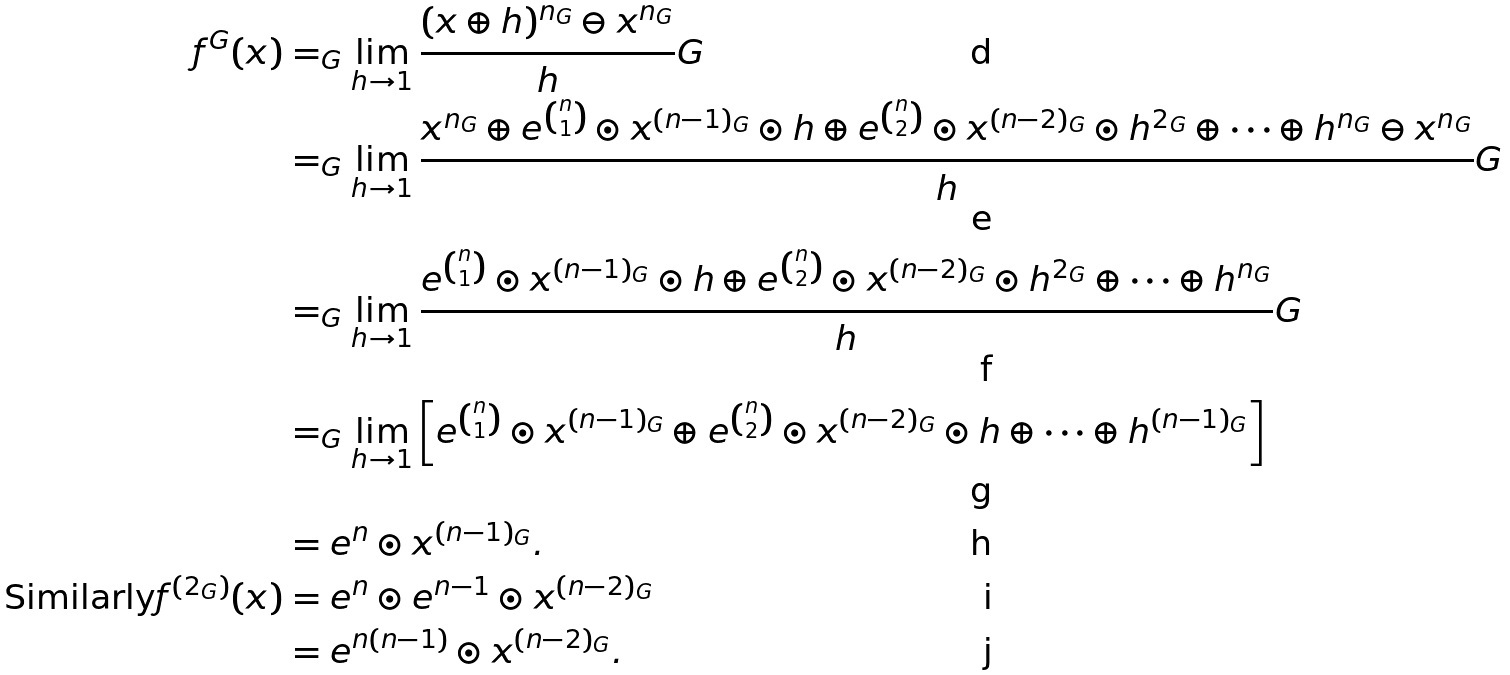Convert formula to latex. <formula><loc_0><loc_0><loc_500><loc_500>f ^ { G } ( x ) & = _ { G } \lim _ { h \rightarrow 1 } \frac { ( x \oplus h ) ^ { n _ { G } } \ominus x ^ { n _ { G } } } { h } G \\ & = _ { G } \lim _ { h \rightarrow 1 } \frac { x ^ { n _ { G } } \oplus e ^ { \binom { n } { 1 } } \odot x ^ { ( n - 1 ) _ { G } } \odot h \oplus e ^ { \binom { n } { 2 } } \odot x ^ { ( n - 2 ) _ { G } } \odot h ^ { 2 _ { G } } \oplus \cdots \oplus h ^ { n _ { G } } \ominus x ^ { n _ { G } } } { h } G \\ & = _ { G } \lim _ { h \rightarrow 1 } \frac { e ^ { \binom { n } { 1 } } \odot x ^ { ( n - 1 ) _ { G } } \odot h \oplus e ^ { \binom { n } { 2 } } \odot x ^ { ( n - 2 ) _ { G } } \odot h ^ { 2 _ { G } } \oplus \cdots \oplus h ^ { n _ { G } } } { h } G \\ & = _ { G } \lim _ { h \rightarrow 1 } \left [ e ^ { \binom { n } { 1 } } \odot x ^ { ( n - 1 ) _ { G } } \oplus e ^ { \binom { n } { 2 } } \odot x ^ { ( n - 2 ) _ { G } } \odot h \oplus \cdots \oplus h ^ { ( n - 1 ) _ { G } } \right ] \\ & = e ^ { n } \odot x ^ { ( n - 1 ) _ { G } } . \\ \text {Similarly} f ^ { ( 2 _ { G } ) } ( x ) & = e ^ { n } \odot e ^ { n - 1 } \odot x ^ { ( n - 2 ) _ { G } } \\ & = e ^ { n ( n - 1 ) } \odot x ^ { ( n - 2 ) _ { G } } .</formula> 